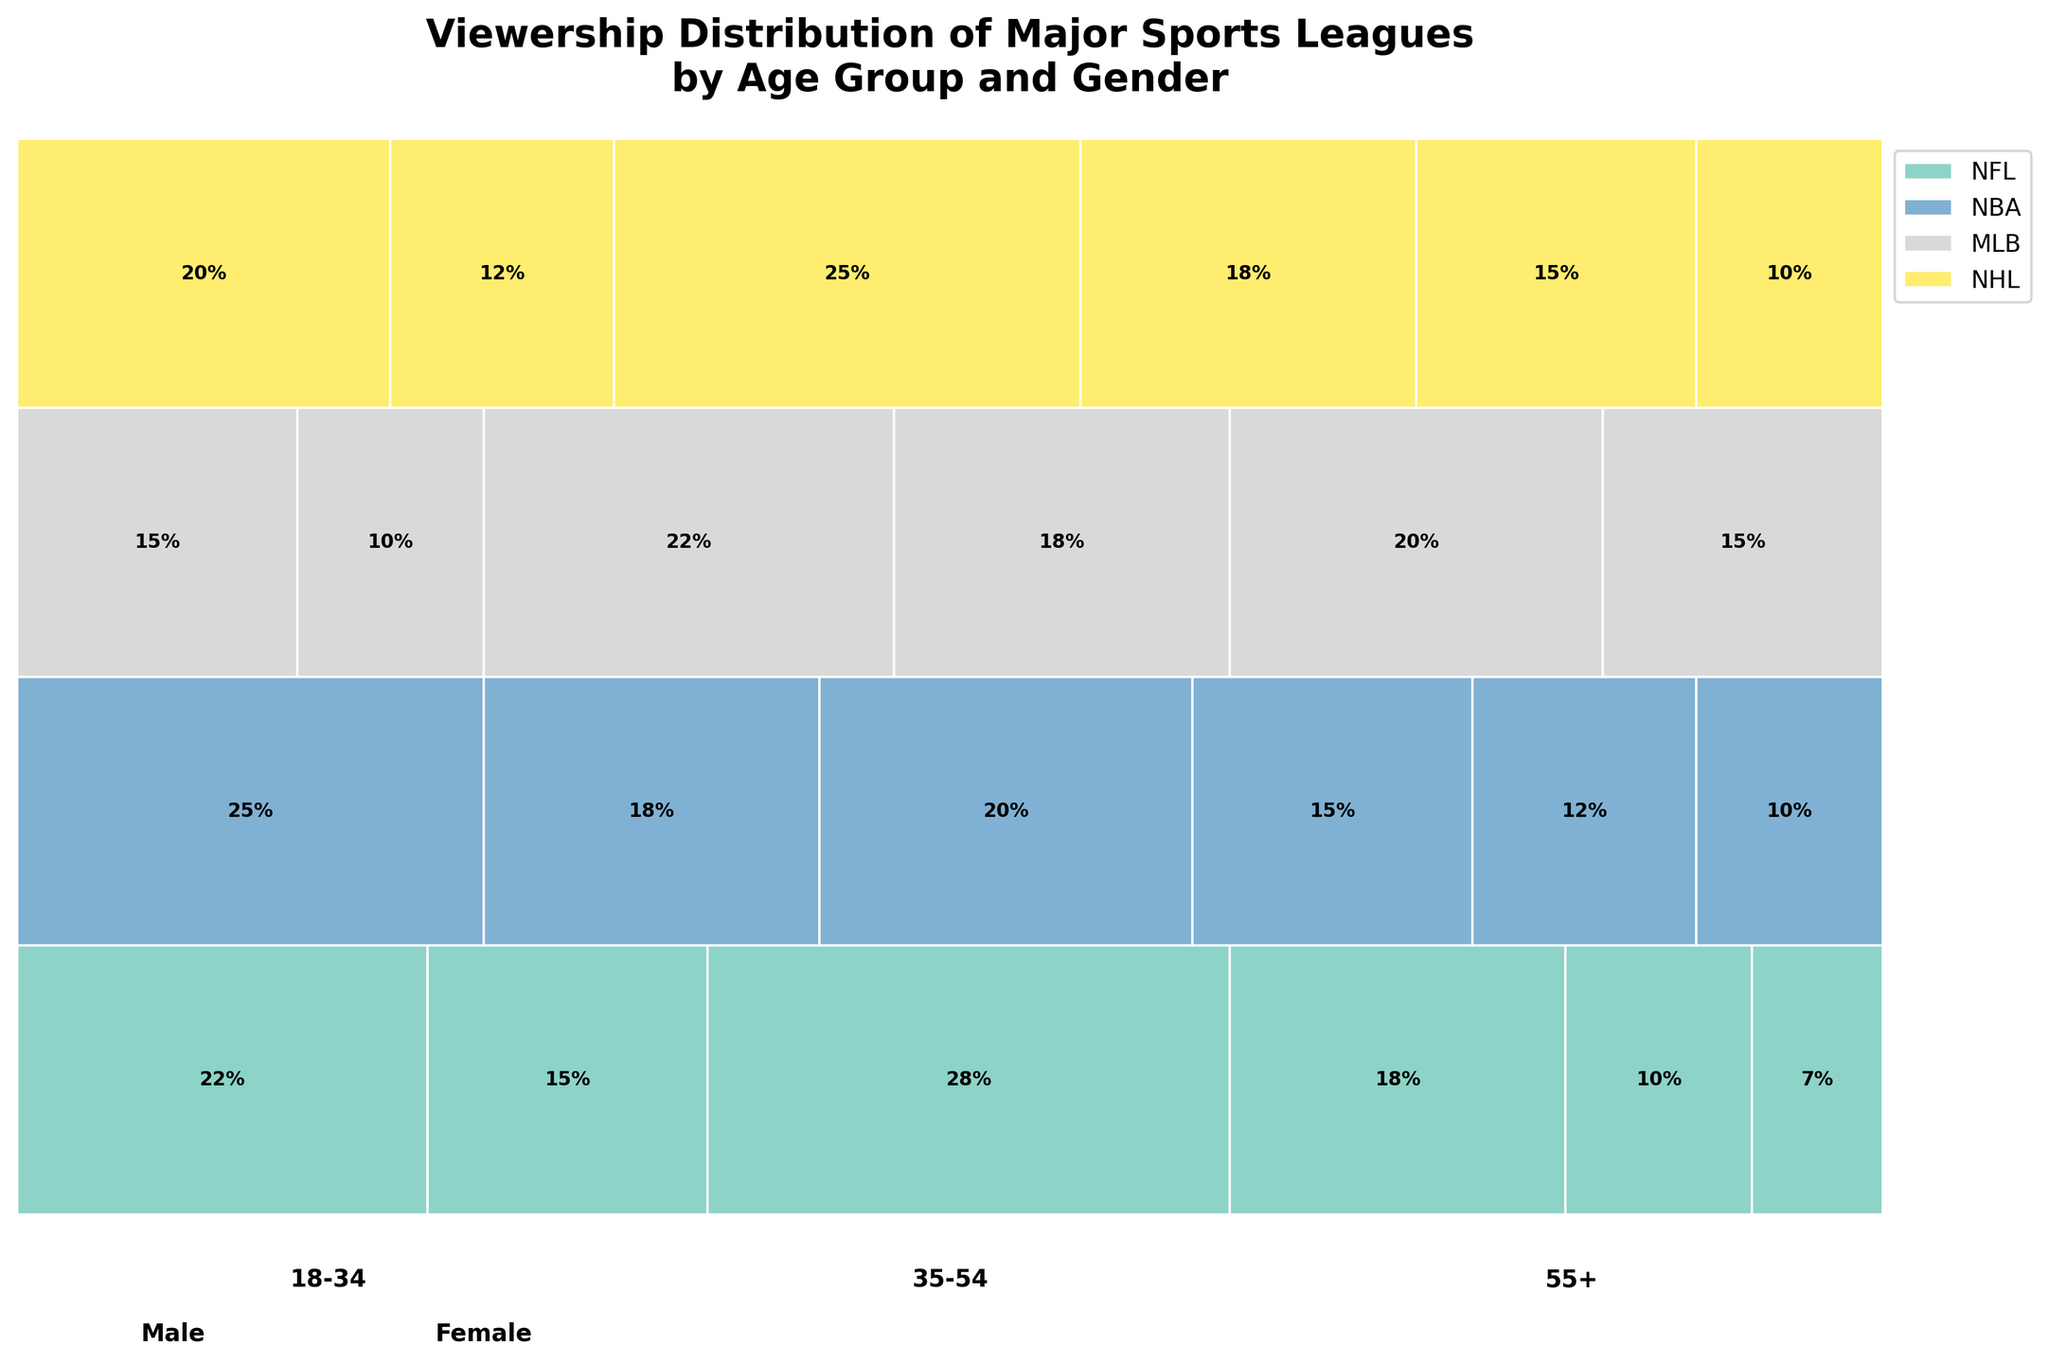What does the title of the figure indicate? The title states "Viewership Distribution of Major Sports Leagues by Age Group and Gender." This tells us that the mosaic plot displays how the viewership of different sports leagues is distributed across various age groups and genders.
Answer: Viewership distribution of major leagues by age and gender Which sports league has the highest viewership percentage according to the plot? By examining the total height (y-offset) of each league's section in the plot, we can see which one is the tallest, hence has the highest viewership percentage. The NFL section is the tallest, indicating it has the most viewership percentage.
Answer: NFL What percentage of NBA viewers are females in the 18-34 age group? Locate the NBA segment, and within that, find the sub-segment for the 18-34 age group. Within that age group, identify the female section and read off its percentage value.
Answer: 18% How does the viewership percentage of males in the 55+ age group compare between the NFL and MLB? Find the segments for males aged 55+ in both the NFL and MLB parts of the mosaic. Compare their widths. For the NFL, it is 10%, whereas for MLB, it is 20%.
Answer: MLB has a higher percentage (20%) What is the total viewership percentage for the 35-54 age group across all leagues? To find the total viewership percentage for the 35-54 age group, sum the respective percentages across all leagues: NFL (28 + 18), NBA (20 + 15), MLB (22 + 18), and NHL (25 + 18). The sum is: (28 + 18) + (20 + 15) + (22 + 18) + (25 + 18) = 164%.
Answer: 164% Which gender shows higher viewership percentages for the NHL within the 35-54 age group? Look at the sub-segments for the 35-54 age group within the NHL section. Compare the heights of the male and female sections. Males have 25% and females 18%.
Answer: Males What is the difference in viewership percentage between males and females in the 35-54 age group for the NBA? Locate the NBA section's 35-54 age group, find the values for males (20%) and females (15%), and calculate the difference. 20% - 15% = 5%.
Answer: 5% How does the combined viewership percentage of females in the 55+ age group compare to that of males in the 18-34 age group for MLB? Combined viewership for females (55+) and males (18-34): Females (MLB, 55+) = 15%, Males (MLB, 18-34) = 15%. Combine these: 15% + 15% = 30%.
Answer: 30% Which age group has the highest viewership percentage for the NFL? Look at the segments for each age group within the NFL section and compare their widths. The age group 35-54 has the highest percentage at 46% (28% males + 18% females).
Answer: 35-54 What is the relative size of the NBA viewership for 18-34 year old males compared to 55+ year old males across all leagues? Compare the percentage for NBA males (18-34) which is 25% to the sum of percentages for males (55+) across all leagues (NFL + NBA + MLB + NHL): 10% + 12% + 20% + 15% = 57%.
Answer: 25% vs 57% 